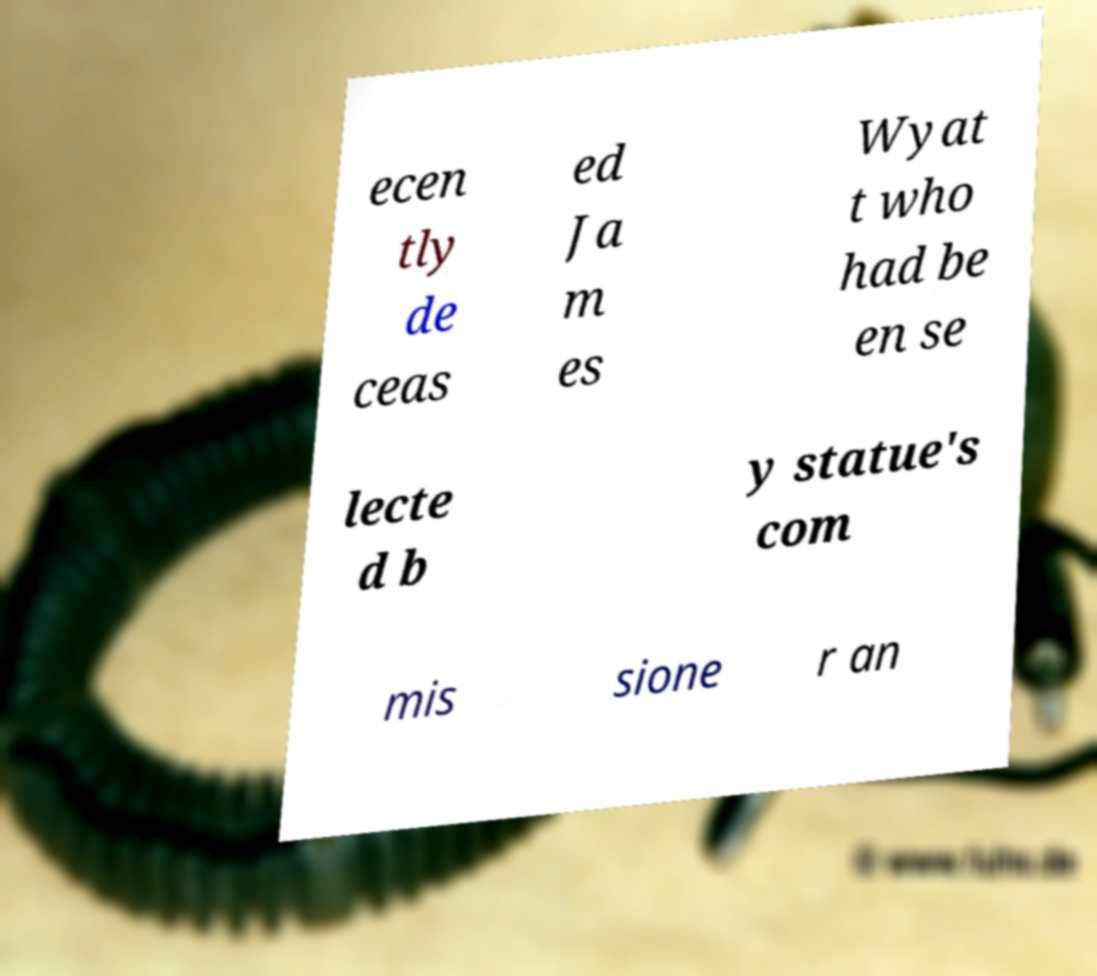I need the written content from this picture converted into text. Can you do that? ecen tly de ceas ed Ja m es Wyat t who had be en se lecte d b y statue's com mis sione r an 